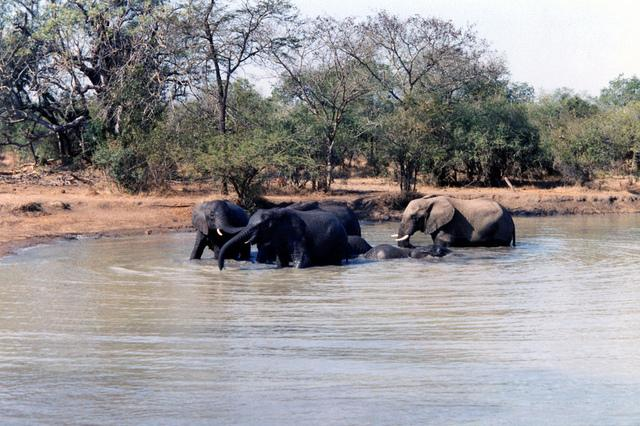Who has the last name that refers to what a group of these animals is called? Please explain your reasoning. jim herd. The name is herd. 